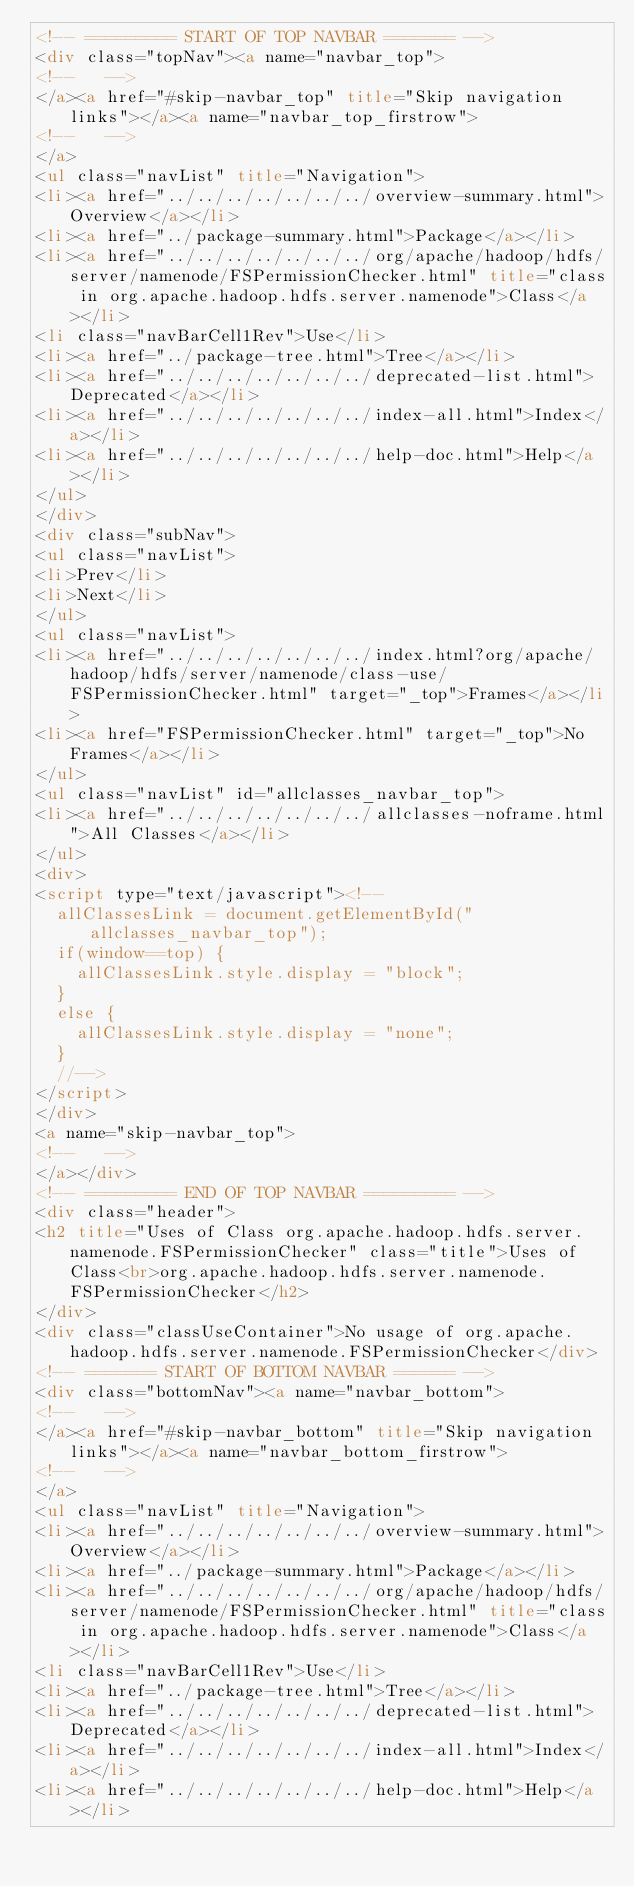Convert code to text. <code><loc_0><loc_0><loc_500><loc_500><_HTML_><!-- ========= START OF TOP NAVBAR ======= -->
<div class="topNav"><a name="navbar_top">
<!--   -->
</a><a href="#skip-navbar_top" title="Skip navigation links"></a><a name="navbar_top_firstrow">
<!--   -->
</a>
<ul class="navList" title="Navigation">
<li><a href="../../../../../../../overview-summary.html">Overview</a></li>
<li><a href="../package-summary.html">Package</a></li>
<li><a href="../../../../../../../org/apache/hadoop/hdfs/server/namenode/FSPermissionChecker.html" title="class in org.apache.hadoop.hdfs.server.namenode">Class</a></li>
<li class="navBarCell1Rev">Use</li>
<li><a href="../package-tree.html">Tree</a></li>
<li><a href="../../../../../../../deprecated-list.html">Deprecated</a></li>
<li><a href="../../../../../../../index-all.html">Index</a></li>
<li><a href="../../../../../../../help-doc.html">Help</a></li>
</ul>
</div>
<div class="subNav">
<ul class="navList">
<li>Prev</li>
<li>Next</li>
</ul>
<ul class="navList">
<li><a href="../../../../../../../index.html?org/apache/hadoop/hdfs/server/namenode/class-use/FSPermissionChecker.html" target="_top">Frames</a></li>
<li><a href="FSPermissionChecker.html" target="_top">No Frames</a></li>
</ul>
<ul class="navList" id="allclasses_navbar_top">
<li><a href="../../../../../../../allclasses-noframe.html">All Classes</a></li>
</ul>
<div>
<script type="text/javascript"><!--
  allClassesLink = document.getElementById("allclasses_navbar_top");
  if(window==top) {
    allClassesLink.style.display = "block";
  }
  else {
    allClassesLink.style.display = "none";
  }
  //-->
</script>
</div>
<a name="skip-navbar_top">
<!--   -->
</a></div>
<!-- ========= END OF TOP NAVBAR ========= -->
<div class="header">
<h2 title="Uses of Class org.apache.hadoop.hdfs.server.namenode.FSPermissionChecker" class="title">Uses of Class<br>org.apache.hadoop.hdfs.server.namenode.FSPermissionChecker</h2>
</div>
<div class="classUseContainer">No usage of org.apache.hadoop.hdfs.server.namenode.FSPermissionChecker</div>
<!-- ======= START OF BOTTOM NAVBAR ====== -->
<div class="bottomNav"><a name="navbar_bottom">
<!--   -->
</a><a href="#skip-navbar_bottom" title="Skip navigation links"></a><a name="navbar_bottom_firstrow">
<!--   -->
</a>
<ul class="navList" title="Navigation">
<li><a href="../../../../../../../overview-summary.html">Overview</a></li>
<li><a href="../package-summary.html">Package</a></li>
<li><a href="../../../../../../../org/apache/hadoop/hdfs/server/namenode/FSPermissionChecker.html" title="class in org.apache.hadoop.hdfs.server.namenode">Class</a></li>
<li class="navBarCell1Rev">Use</li>
<li><a href="../package-tree.html">Tree</a></li>
<li><a href="../../../../../../../deprecated-list.html">Deprecated</a></li>
<li><a href="../../../../../../../index-all.html">Index</a></li>
<li><a href="../../../../../../../help-doc.html">Help</a></li></code> 